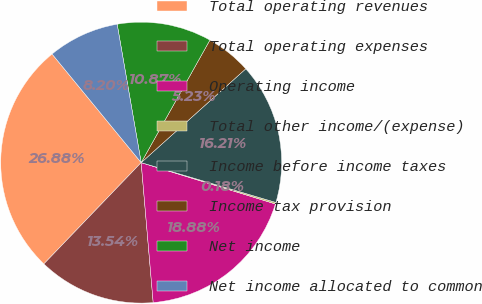Convert chart. <chart><loc_0><loc_0><loc_500><loc_500><pie_chart><fcel>Total operating revenues<fcel>Total operating expenses<fcel>Operating income<fcel>Total other income/(expense)<fcel>Income before income taxes<fcel>Income tax provision<fcel>Net income<fcel>Net income allocated to common<nl><fcel>26.88%<fcel>13.54%<fcel>18.88%<fcel>0.18%<fcel>16.21%<fcel>5.23%<fcel>10.87%<fcel>8.2%<nl></chart> 